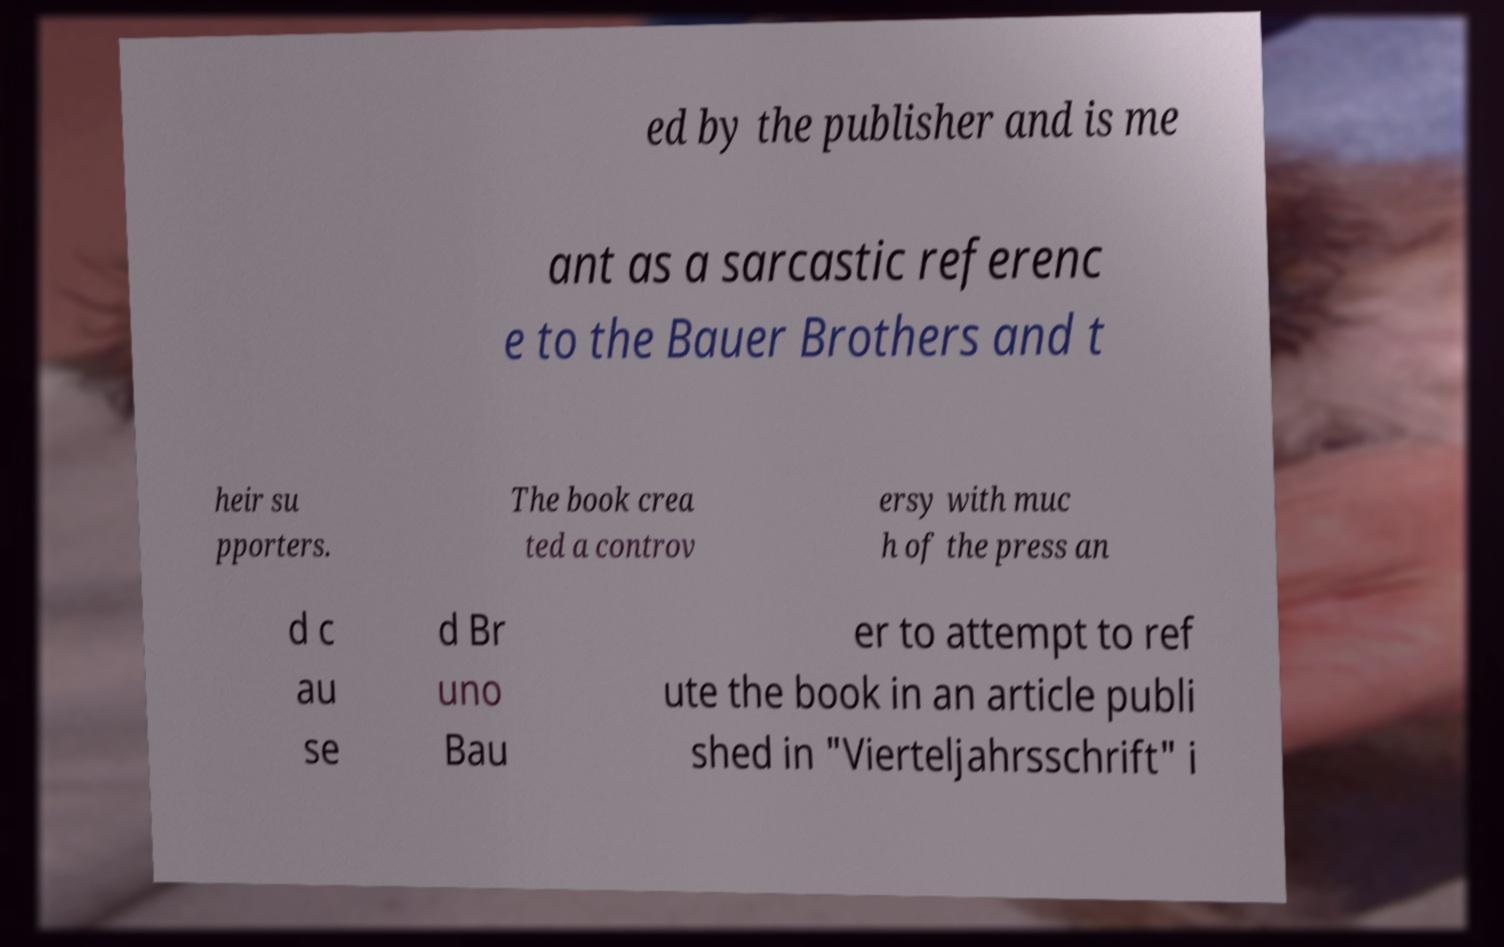For documentation purposes, I need the text within this image transcribed. Could you provide that? ed by the publisher and is me ant as a sarcastic referenc e to the Bauer Brothers and t heir su pporters. The book crea ted a controv ersy with muc h of the press an d c au se d Br uno Bau er to attempt to ref ute the book in an article publi shed in "Vierteljahrsschrift" i 